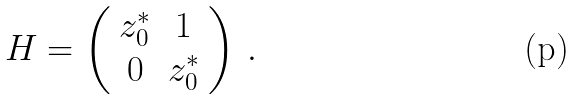Convert formula to latex. <formula><loc_0><loc_0><loc_500><loc_500>H = \left ( \begin{array} { c c } z _ { 0 } ^ { * } & 1 \\ 0 & z _ { 0 } ^ { * } \\ \end{array} \right ) \, .</formula> 